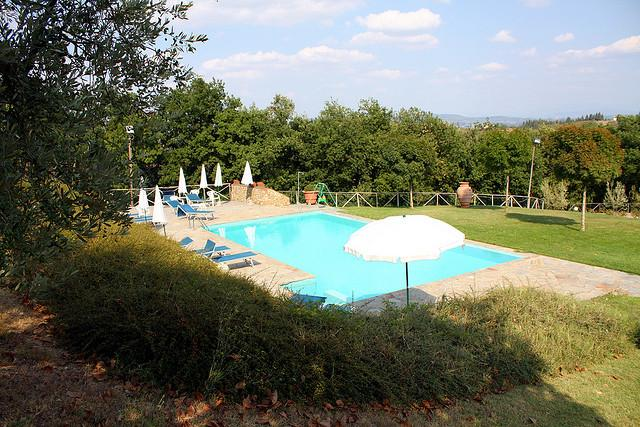Where is this pool located at?

Choices:
A) resort
B) public park
C) winery
D) backyard backyard 